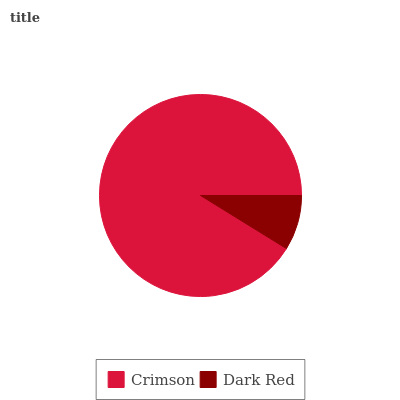Is Dark Red the minimum?
Answer yes or no. Yes. Is Crimson the maximum?
Answer yes or no. Yes. Is Dark Red the maximum?
Answer yes or no. No. Is Crimson greater than Dark Red?
Answer yes or no. Yes. Is Dark Red less than Crimson?
Answer yes or no. Yes. Is Dark Red greater than Crimson?
Answer yes or no. No. Is Crimson less than Dark Red?
Answer yes or no. No. Is Crimson the high median?
Answer yes or no. Yes. Is Dark Red the low median?
Answer yes or no. Yes. Is Dark Red the high median?
Answer yes or no. No. Is Crimson the low median?
Answer yes or no. No. 